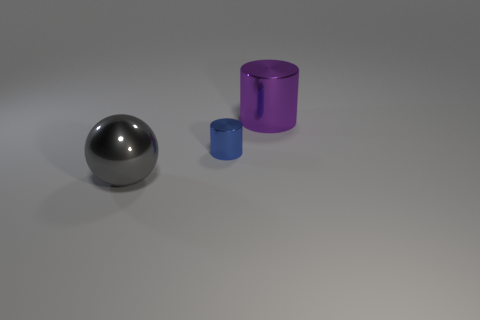Add 1 large balls. How many objects exist? 4 Subtract all cylinders. How many objects are left? 1 Add 2 large cylinders. How many large cylinders exist? 3 Subtract 0 cyan cubes. How many objects are left? 3 Subtract all tiny metal cylinders. Subtract all small shiny things. How many objects are left? 1 Add 1 large purple metal cylinders. How many large purple metal cylinders are left? 2 